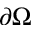<formula> <loc_0><loc_0><loc_500><loc_500>\partial \Omega</formula> 